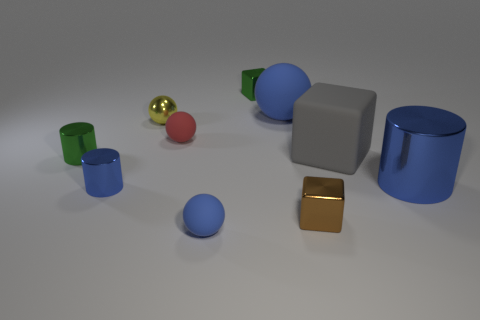The green cylinder has what size?
Your answer should be compact. Small. Does the red rubber thing have the same size as the brown block?
Your response must be concise. Yes. What is the material of the blue sphere behind the large block?
Your answer should be compact. Rubber. What is the material of the large gray object that is the same shape as the tiny brown metallic thing?
Offer a terse response. Rubber. Are there any cylinders that are right of the metallic object on the left side of the tiny blue cylinder?
Ensure brevity in your answer.  Yes. Does the big gray rubber thing have the same shape as the brown metallic object?
Ensure brevity in your answer.  Yes. There is a big object that is made of the same material as the green cylinder; what is its shape?
Provide a short and direct response. Cylinder. Does the blue metal cylinder that is left of the big blue cylinder have the same size as the blue sphere in front of the small blue cylinder?
Provide a succinct answer. Yes. Are there more small green shiny things behind the tiny green cylinder than yellow objects that are to the left of the small blue shiny cylinder?
Your answer should be compact. Yes. What number of other things are the same color as the big cylinder?
Offer a very short reply. 3. 